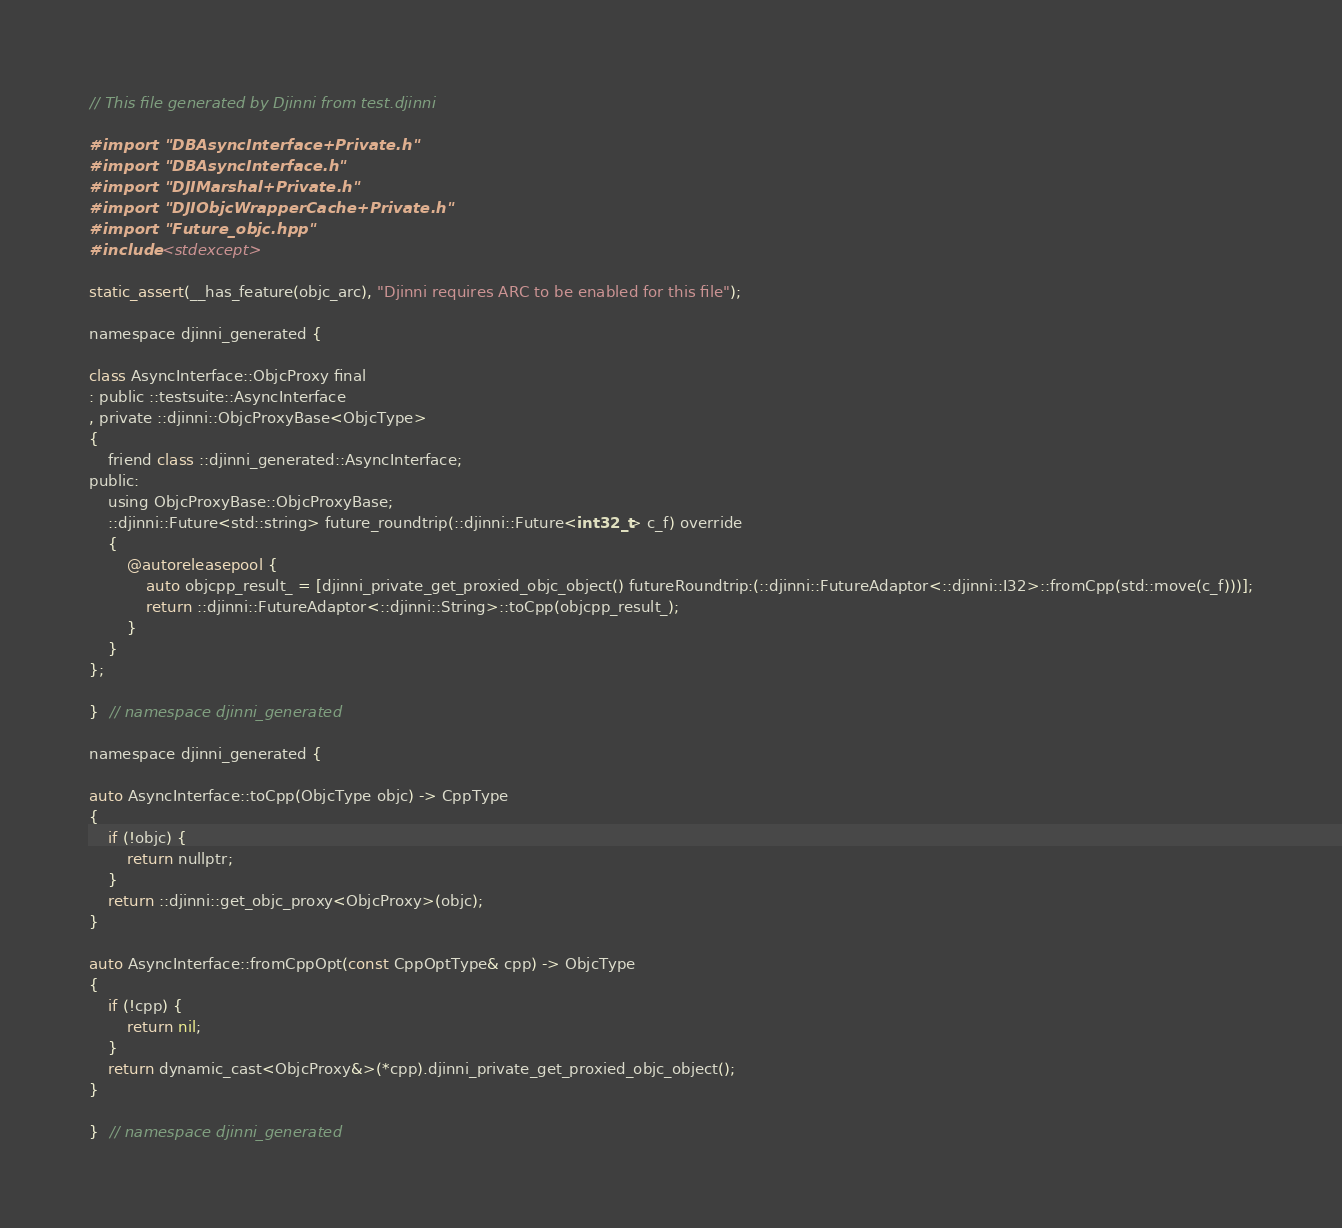Convert code to text. <code><loc_0><loc_0><loc_500><loc_500><_ObjectiveC_>// This file generated by Djinni from test.djinni

#import "DBAsyncInterface+Private.h"
#import "DBAsyncInterface.h"
#import "DJIMarshal+Private.h"
#import "DJIObjcWrapperCache+Private.h"
#import "Future_objc.hpp"
#include <stdexcept>

static_assert(__has_feature(objc_arc), "Djinni requires ARC to be enabled for this file");

namespace djinni_generated {

class AsyncInterface::ObjcProxy final
: public ::testsuite::AsyncInterface
, private ::djinni::ObjcProxyBase<ObjcType>
{
    friend class ::djinni_generated::AsyncInterface;
public:
    using ObjcProxyBase::ObjcProxyBase;
    ::djinni::Future<std::string> future_roundtrip(::djinni::Future<int32_t> c_f) override
    {
        @autoreleasepool {
            auto objcpp_result_ = [djinni_private_get_proxied_objc_object() futureRoundtrip:(::djinni::FutureAdaptor<::djinni::I32>::fromCpp(std::move(c_f)))];
            return ::djinni::FutureAdaptor<::djinni::String>::toCpp(objcpp_result_);
        }
    }
};

}  // namespace djinni_generated

namespace djinni_generated {

auto AsyncInterface::toCpp(ObjcType objc) -> CppType
{
    if (!objc) {
        return nullptr;
    }
    return ::djinni::get_objc_proxy<ObjcProxy>(objc);
}

auto AsyncInterface::fromCppOpt(const CppOptType& cpp) -> ObjcType
{
    if (!cpp) {
        return nil;
    }
    return dynamic_cast<ObjcProxy&>(*cpp).djinni_private_get_proxied_objc_object();
}

}  // namespace djinni_generated
</code> 